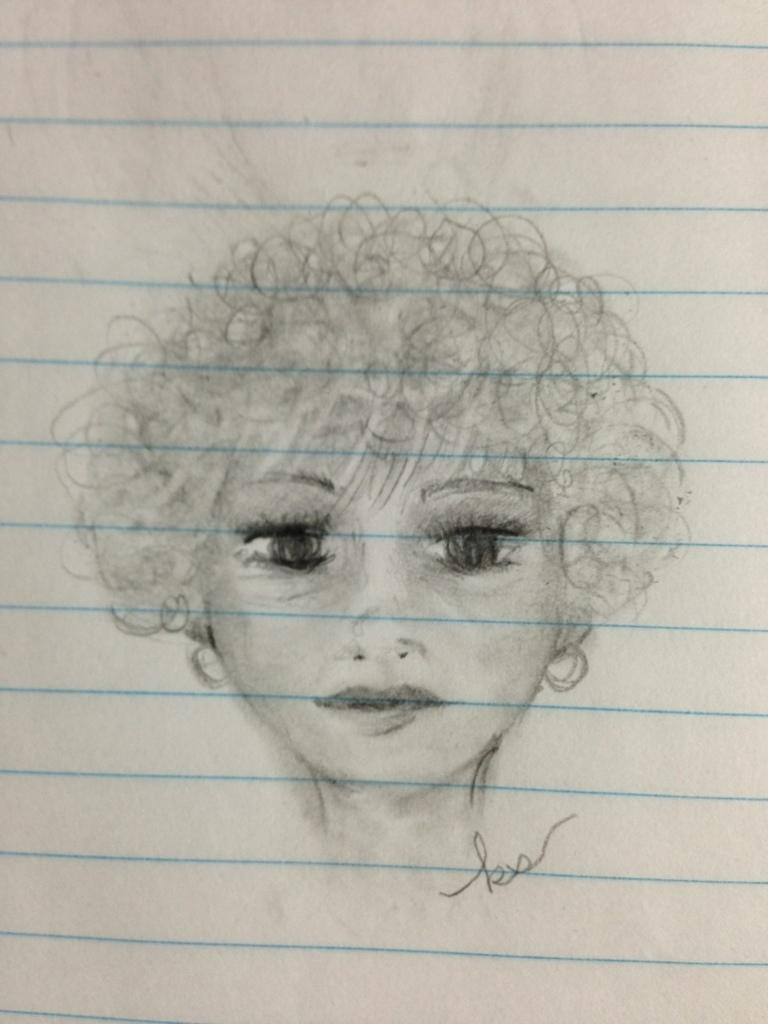What is depicted in the image? There is a sketch of a person in the image. What is the medium of the sketch? The sketch is on a paper. How many people are in the group depicted in the image? There is no group depicted in the image; it only features a sketch of a single person. What type of stove is shown in the image? There is no stove present in the image; it only contains a sketch of a person on a paper. 